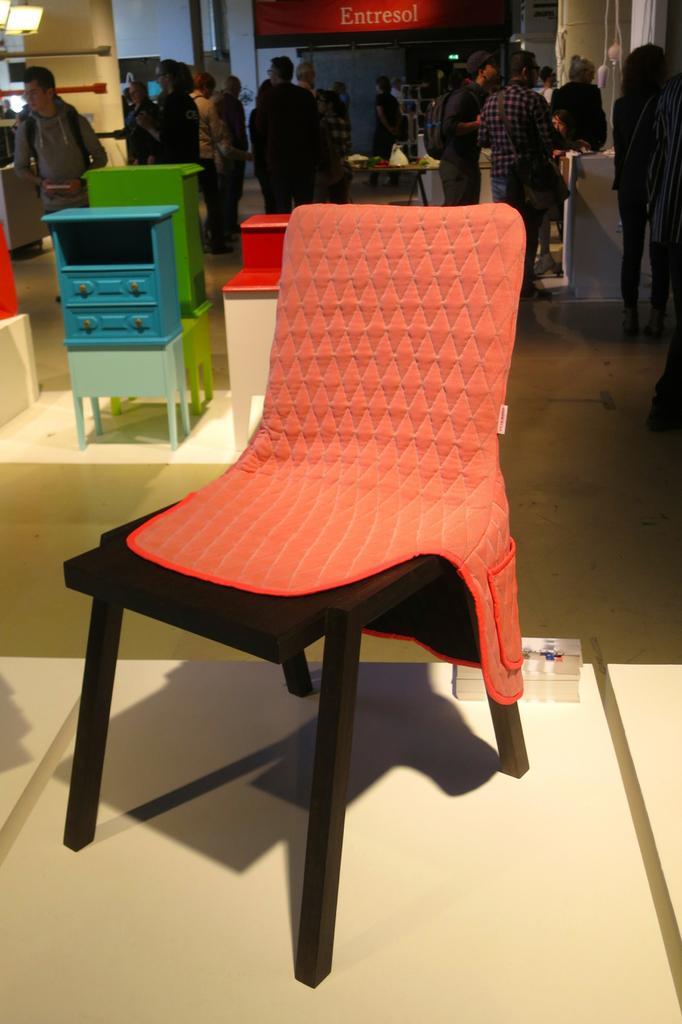Describe this image in one or two sentences. In Front portion of the picture we can see an empty chair here. On the background we can see few persons standing and walking. This is a hoarding. 